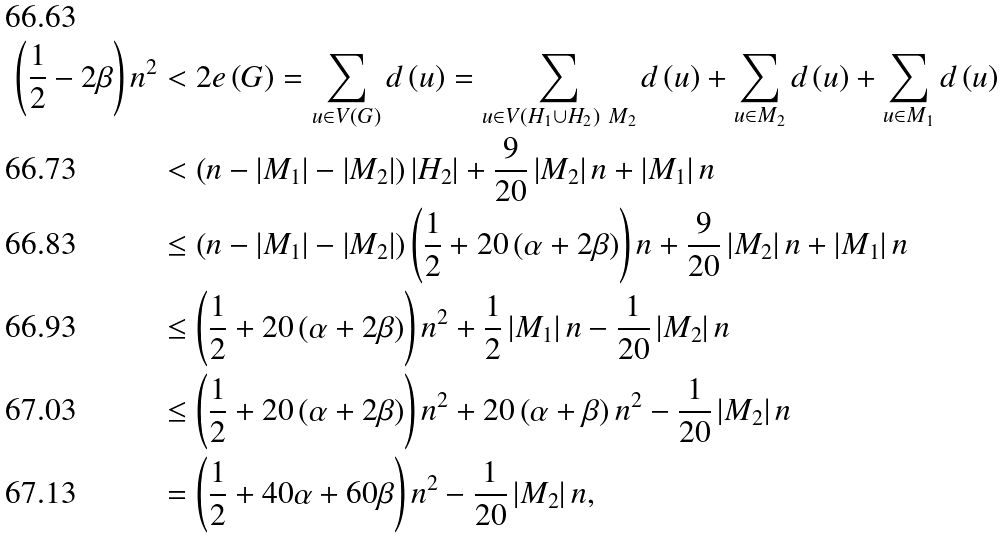Convert formula to latex. <formula><loc_0><loc_0><loc_500><loc_500>\left ( \frac { 1 } { 2 } - 2 \beta \right ) n ^ { 2 } & < 2 e \left ( G \right ) = \sum _ { u \in V \left ( G \right ) } d \left ( u \right ) = \sum _ { u \in V \left ( H _ { 1 } \cup H _ { 2 } \right ) \ M _ { 2 } } d \left ( u \right ) + \sum _ { u \in M _ { 2 } } d \left ( u \right ) + \sum _ { u \in M _ { 1 } } d \left ( u \right ) \\ & < \left ( n - \left | M _ { 1 } \right | - \left | M _ { 2 } \right | \right ) \left | H _ { 2 } \right | + \frac { 9 } { 2 0 } \left | M _ { 2 } \right | n + \left | M _ { 1 } \right | n \\ & \leq \left ( n - \left | M _ { 1 } \right | - \left | M _ { 2 } \right | \right ) \left ( \frac { 1 } { 2 } + 2 0 \left ( \alpha + 2 \beta \right ) \right ) n + \frac { 9 } { 2 0 } \left | M _ { 2 } \right | n + \left | M _ { 1 } \right | n \\ & \leq \left ( \frac { 1 } { 2 } + 2 0 \left ( \alpha + 2 \beta \right ) \right ) n ^ { 2 } + \frac { 1 } { 2 } \left | M _ { 1 } \right | n - \frac { 1 } { 2 0 } \left | M _ { 2 } \right | n \\ & \leq \left ( \frac { 1 } { 2 } + 2 0 \left ( \alpha + 2 \beta \right ) \right ) n ^ { 2 } + 2 0 \left ( \alpha + \beta \right ) n ^ { 2 } - \frac { 1 } { 2 0 } \left | M _ { 2 } \right | n \\ & = \left ( \frac { 1 } { 2 } + 4 0 \alpha + 6 0 \beta \right ) n ^ { 2 } - \frac { 1 } { 2 0 } \left | M _ { 2 } \right | n ,</formula> 